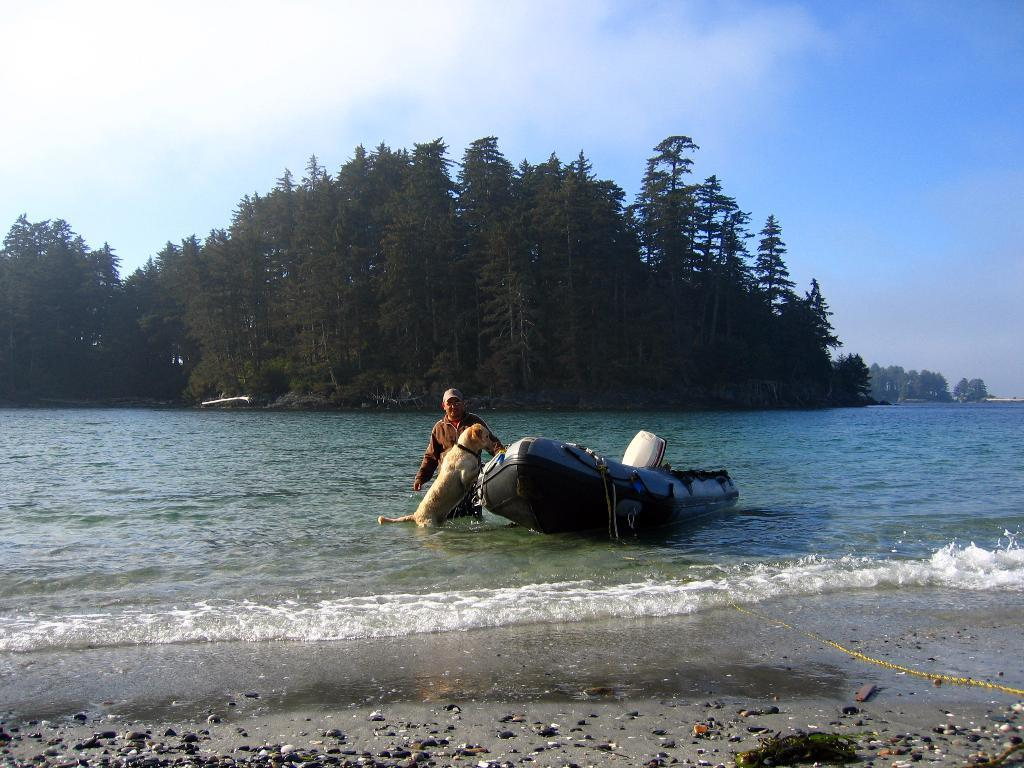What is the main subject of the image? The main subject of the image is a boat. Where is the boat located? The boat is on the water. What other objects or living beings can be seen in the image? There are sandstones, a dog, and a person in the image. What is visible in the background of the image? Trees and the sky are visible in the background of the image. Can you describe the sky in the image? The sky is visible in the background of the image, and clouds are present. How does the mother interact with the boat in the image? There is no mention of a mother in the image, so it is not possible to answer this question. 